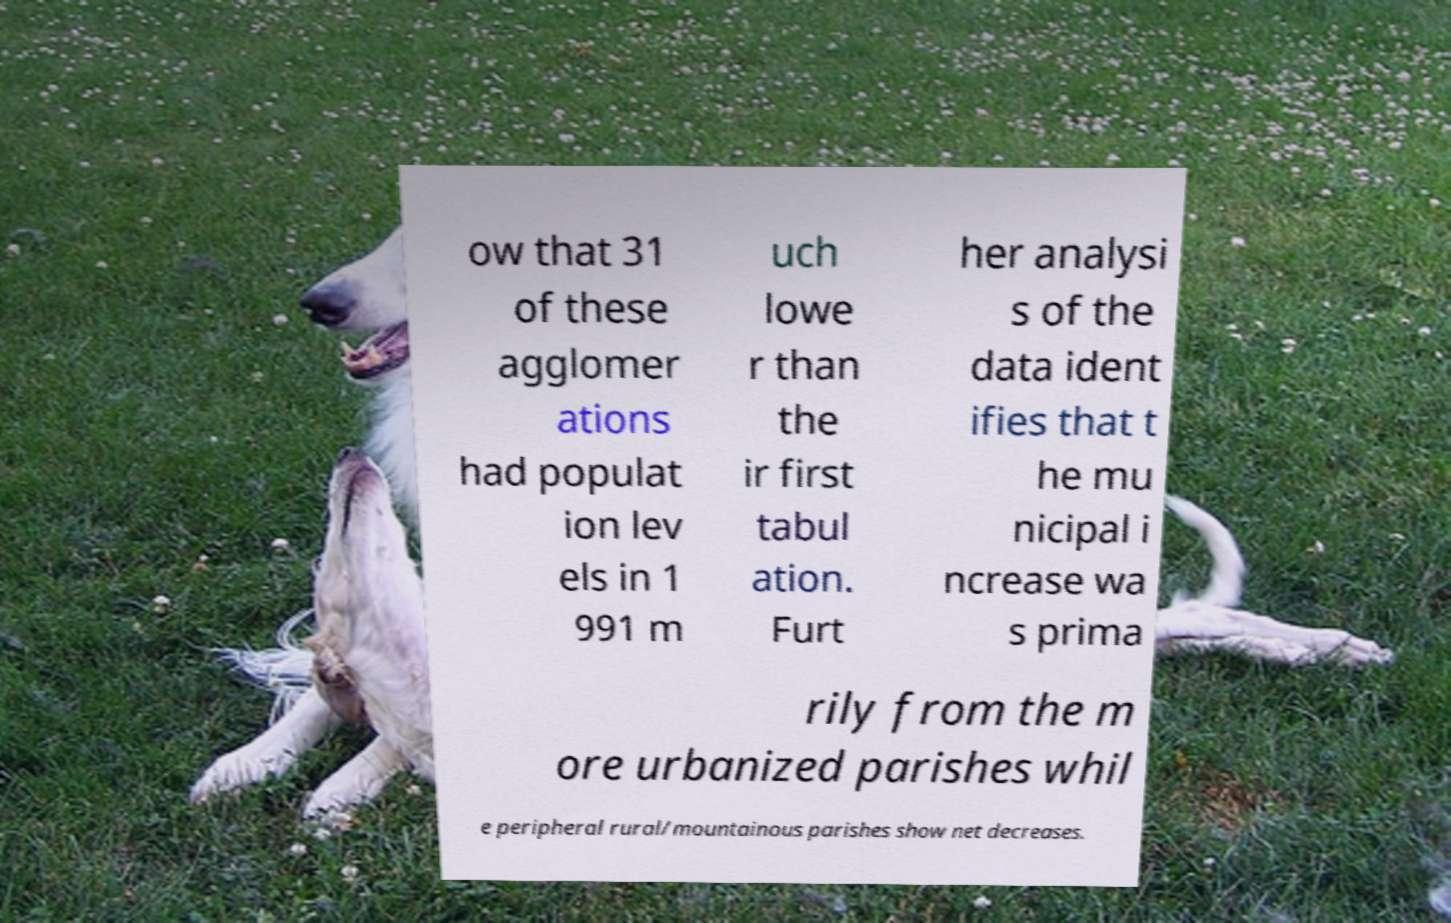Can you accurately transcribe the text from the provided image for me? ow that 31 of these agglomer ations had populat ion lev els in 1 991 m uch lowe r than the ir first tabul ation. Furt her analysi s of the data ident ifies that t he mu nicipal i ncrease wa s prima rily from the m ore urbanized parishes whil e peripheral rural/mountainous parishes show net decreases. 